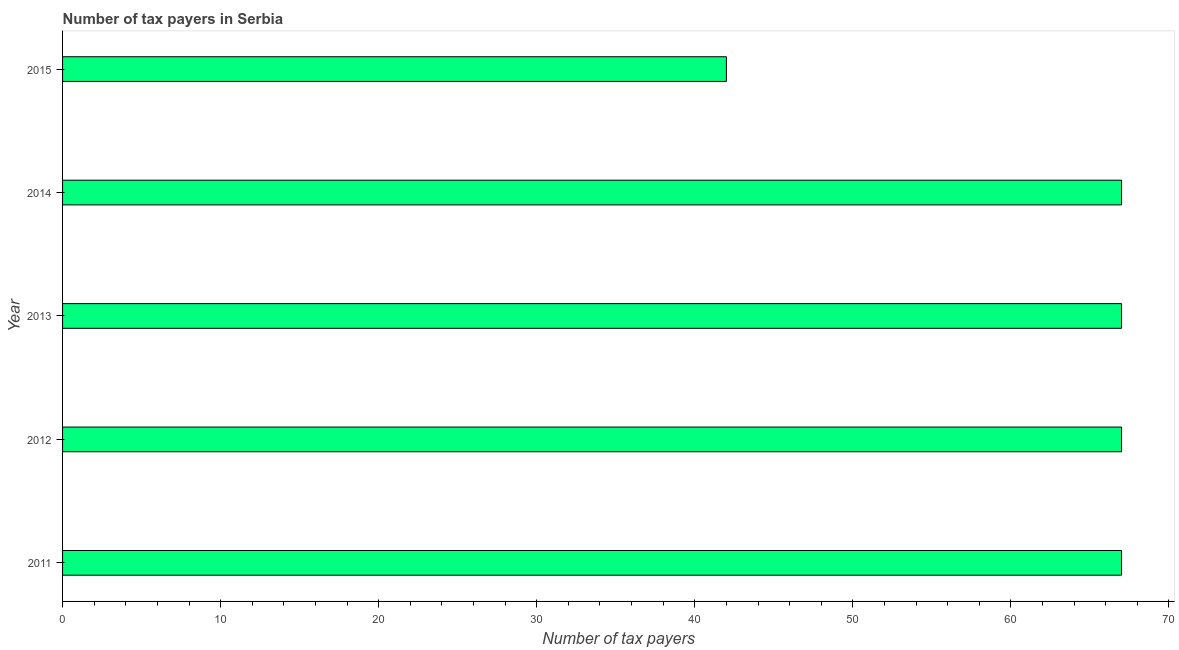What is the title of the graph?
Offer a terse response. Number of tax payers in Serbia. What is the label or title of the X-axis?
Offer a very short reply. Number of tax payers. What is the label or title of the Y-axis?
Make the answer very short. Year. What is the number of tax payers in 2015?
Your answer should be very brief. 42. In which year was the number of tax payers maximum?
Keep it short and to the point. 2011. In which year was the number of tax payers minimum?
Offer a very short reply. 2015. What is the sum of the number of tax payers?
Your answer should be compact. 310. What is the difference between the number of tax payers in 2012 and 2013?
Your answer should be compact. 0. What is the average number of tax payers per year?
Your response must be concise. 62. Is the number of tax payers in 2014 less than that in 2015?
Your response must be concise. No. What is the difference between the highest and the second highest number of tax payers?
Keep it short and to the point. 0. Is the sum of the number of tax payers in 2011 and 2014 greater than the maximum number of tax payers across all years?
Give a very brief answer. Yes. What is the difference between the highest and the lowest number of tax payers?
Offer a terse response. 25. How many bars are there?
Give a very brief answer. 5. What is the Number of tax payers in 2014?
Your response must be concise. 67. What is the difference between the Number of tax payers in 2011 and 2012?
Keep it short and to the point. 0. What is the difference between the Number of tax payers in 2012 and 2014?
Give a very brief answer. 0. What is the difference between the Number of tax payers in 2012 and 2015?
Keep it short and to the point. 25. What is the difference between the Number of tax payers in 2013 and 2014?
Your answer should be very brief. 0. What is the ratio of the Number of tax payers in 2011 to that in 2012?
Keep it short and to the point. 1. What is the ratio of the Number of tax payers in 2011 to that in 2013?
Give a very brief answer. 1. What is the ratio of the Number of tax payers in 2011 to that in 2015?
Ensure brevity in your answer.  1.59. What is the ratio of the Number of tax payers in 2012 to that in 2014?
Your answer should be compact. 1. What is the ratio of the Number of tax payers in 2012 to that in 2015?
Your answer should be very brief. 1.59. What is the ratio of the Number of tax payers in 2013 to that in 2015?
Make the answer very short. 1.59. What is the ratio of the Number of tax payers in 2014 to that in 2015?
Ensure brevity in your answer.  1.59. 